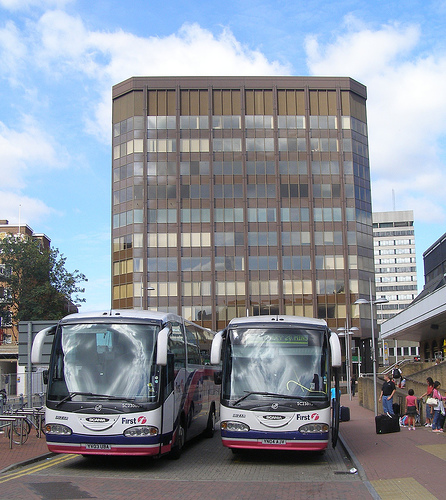Is there either a white mirror or couch? No, the image features buses and people without any clear sight of a mirror or couch, particularly not in white. 